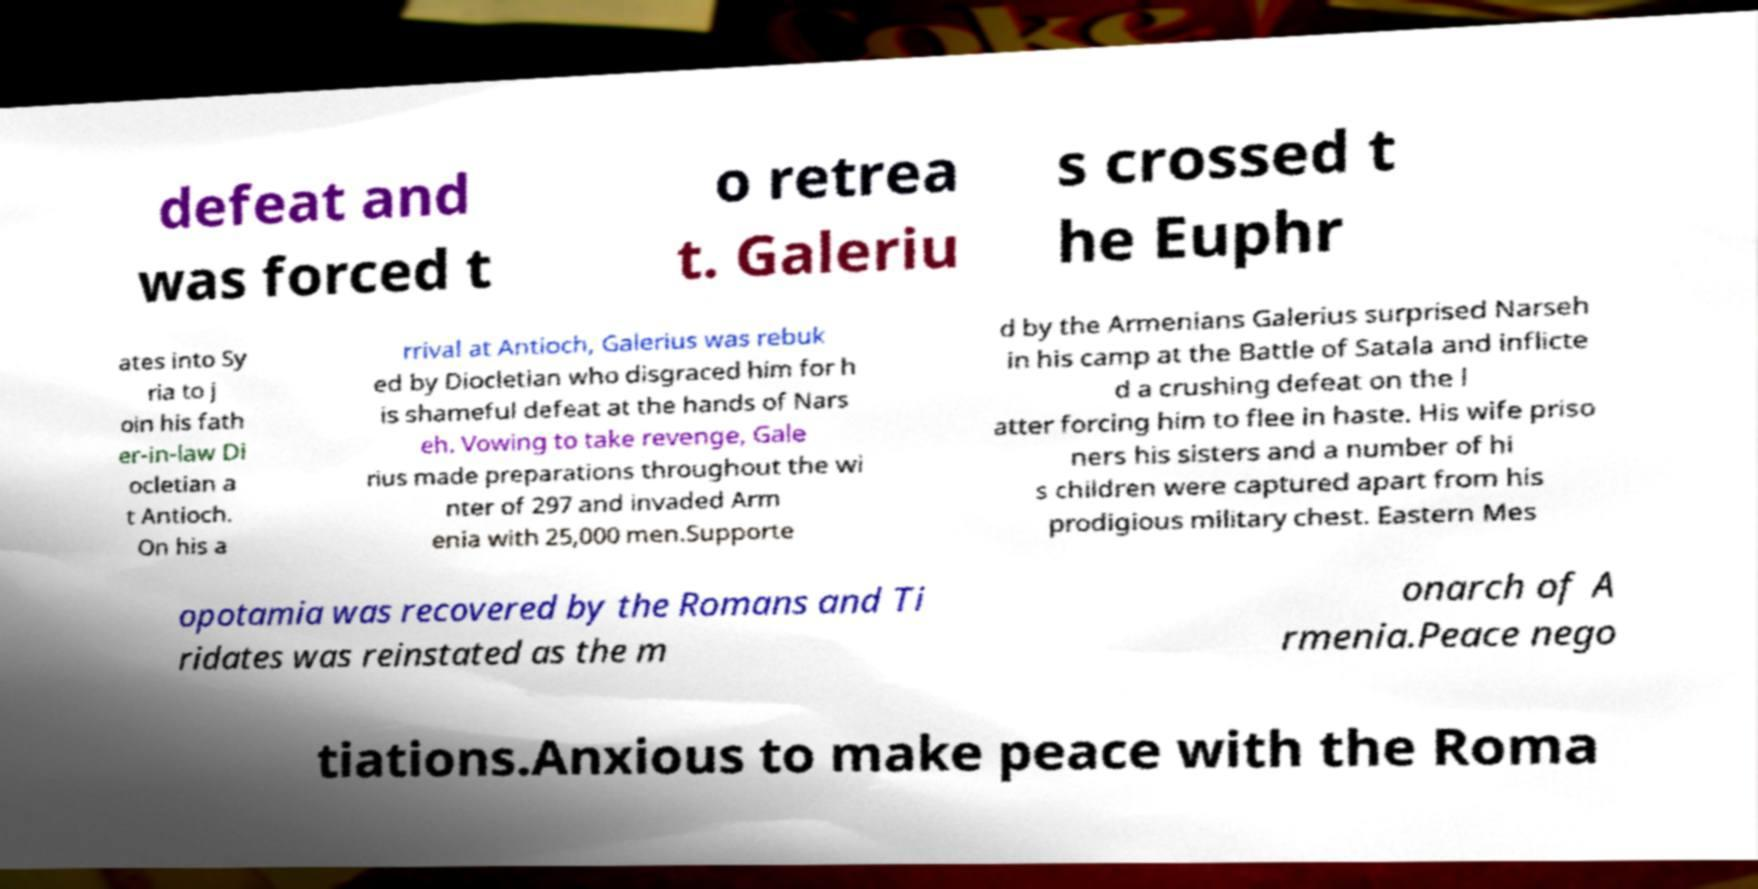For documentation purposes, I need the text within this image transcribed. Could you provide that? defeat and was forced t o retrea t. Galeriu s crossed t he Euphr ates into Sy ria to j oin his fath er-in-law Di ocletian a t Antioch. On his a rrival at Antioch, Galerius was rebuk ed by Diocletian who disgraced him for h is shameful defeat at the hands of Nars eh. Vowing to take revenge, Gale rius made preparations throughout the wi nter of 297 and invaded Arm enia with 25,000 men.Supporte d by the Armenians Galerius surprised Narseh in his camp at the Battle of Satala and inflicte d a crushing defeat on the l atter forcing him to flee in haste. His wife priso ners his sisters and a number of hi s children were captured apart from his prodigious military chest. Eastern Mes opotamia was recovered by the Romans and Ti ridates was reinstated as the m onarch of A rmenia.Peace nego tiations.Anxious to make peace with the Roma 